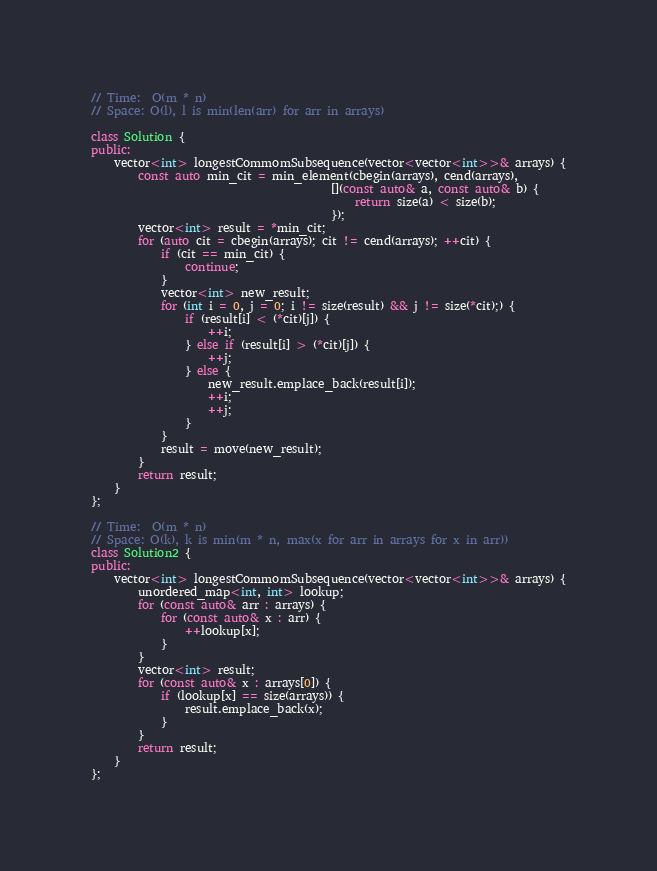Convert code to text. <code><loc_0><loc_0><loc_500><loc_500><_C++_>// Time:  O(m * n)
// Space: O(l), l is min(len(arr) for arr in arrays)

class Solution {
public:
    vector<int> longestCommomSubsequence(vector<vector<int>>& arrays) {
        const auto min_cit = min_element(cbegin(arrays), cend(arrays),
                                         [](const auto& a, const auto& b) {
                                             return size(a) < size(b);
                                         });
        vector<int> result = *min_cit;
        for (auto cit = cbegin(arrays); cit != cend(arrays); ++cit) {
            if (cit == min_cit) {
                continue;
            }
            vector<int> new_result;
            for (int i = 0, j = 0; i != size(result) && j != size(*cit);) {
                if (result[i] < (*cit)[j]) {
                    ++i;
                } else if (result[i] > (*cit)[j]) {
                    ++j;
                } else {
                    new_result.emplace_back(result[i]);
                    ++i;
                    ++j;
                }
            }
            result = move(new_result);
        }
        return result;
    }
};

// Time:  O(m * n)
// Space: O(k), k is min(m * n, max(x for arr in arrays for x in arr))
class Solution2 {
public:
    vector<int> longestCommomSubsequence(vector<vector<int>>& arrays) {
        unordered_map<int, int> lookup;
        for (const auto& arr : arrays) {
            for (const auto& x : arr) {
                ++lookup[x];
            }
        }
        vector<int> result;
        for (const auto& x : arrays[0]) {
            if (lookup[x] == size(arrays)) {
                result.emplace_back(x);
            }
        }
        return result;
    }
};
</code> 